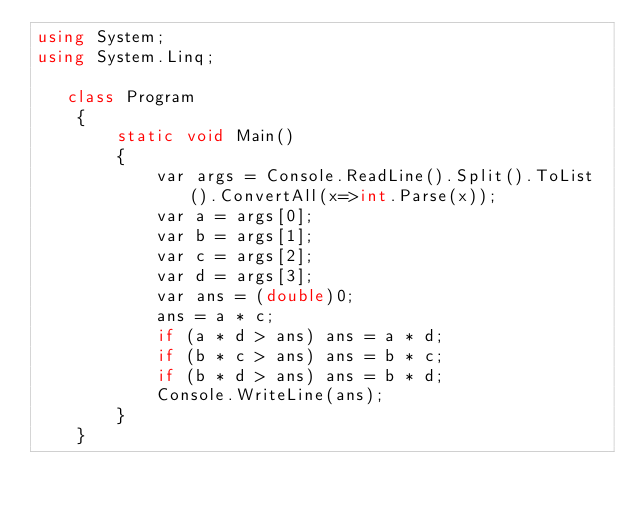<code> <loc_0><loc_0><loc_500><loc_500><_C#_>using System;
using System.Linq;

   class Program
    {
        static void Main()
        {
            var args = Console.ReadLine().Split().ToList().ConvertAll(x=>int.Parse(x));
            var a = args[0];
            var b = args[1];
            var c = args[2];
            var d = args[3];
            var ans = (double)0;
            ans = a * c;
            if (a * d > ans) ans = a * d;
            if (b * c > ans) ans = b * c;
            if (b * d > ans) ans = b * d;
            Console.WriteLine(ans);
        }
    }</code> 